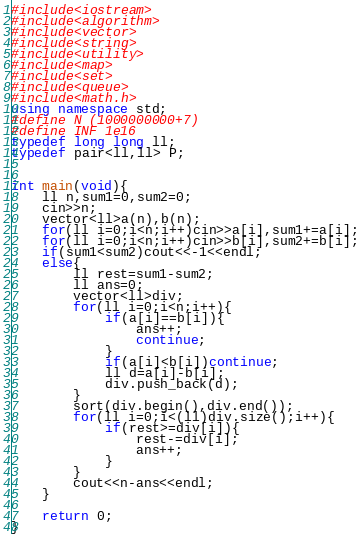<code> <loc_0><loc_0><loc_500><loc_500><_C++_>#include<iostream>
#include<algorithm>
#include<vector>
#include<string>
#include<utility>
#include<map>
#include<set>
#include<queue>
#include<math.h>
using namespace std;
#define N (1000000000+7)
#define INF 1e16
typedef long long ll;
typedef pair<ll,ll> P;


int main(void){
    ll n,sum1=0,sum2=0;
    cin>>n;
    vector<ll>a(n),b(n);
    for(ll i=0;i<n;i++)cin>>a[i],sum1+=a[i];
    for(ll i=0;i<n;i++)cin>>b[i],sum2+=b[i];
    if(sum1<sum2)cout<<-1<<endl;
    else{
        ll rest=sum1-sum2;
        ll ans=0;
        vector<ll>div;
        for(ll i=0;i<n;i++){
            if(a[i]==b[i]){
                ans++;
                continue;
            }
            if(a[i]<b[i])continue;
            ll d=a[i]-b[i];
            div.push_back(d);
        }
        sort(div.begin(),div.end());
        for(ll i=0;i<(ll)div.size();i++){
            if(rest>=div[i]){
                rest-=div[i];
                ans++;
            }
        }
        cout<<n-ans<<endl;
    }

    return 0;
}
</code> 